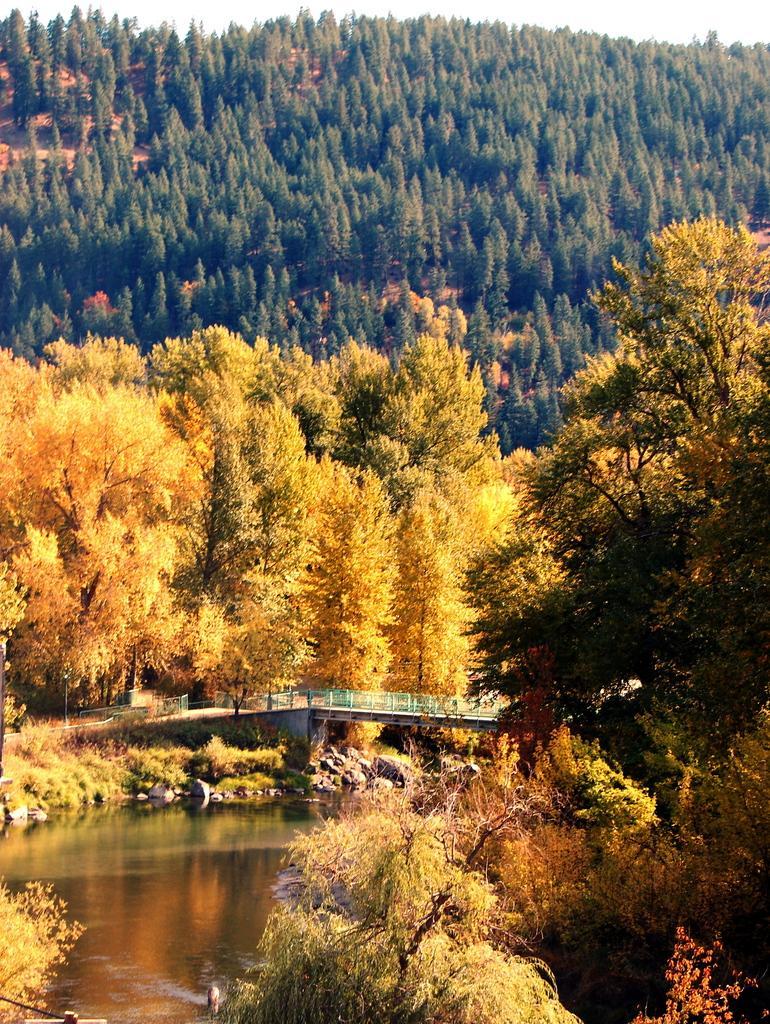How would you summarize this image in a sentence or two? In this image we can see water, bridge, trees and sky in the background. 